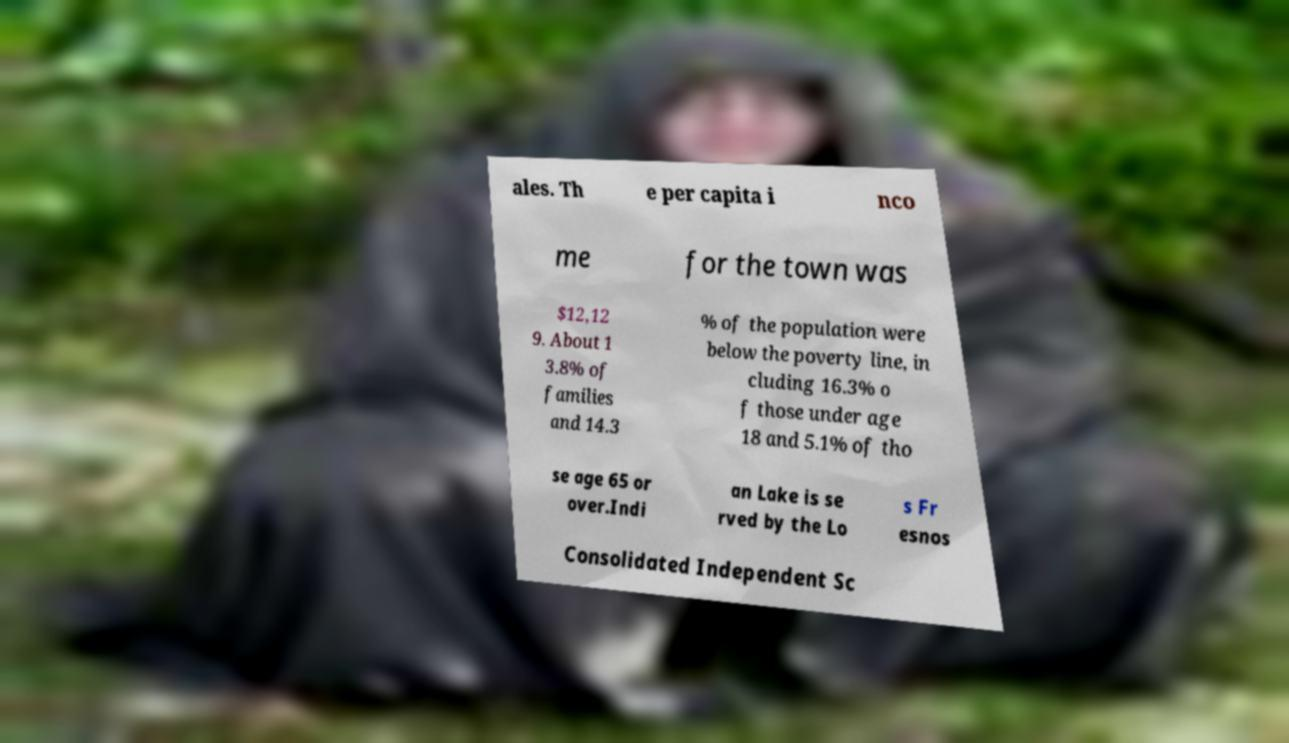For documentation purposes, I need the text within this image transcribed. Could you provide that? ales. Th e per capita i nco me for the town was $12,12 9. About 1 3.8% of families and 14.3 % of the population were below the poverty line, in cluding 16.3% o f those under age 18 and 5.1% of tho se age 65 or over.Indi an Lake is se rved by the Lo s Fr esnos Consolidated Independent Sc 